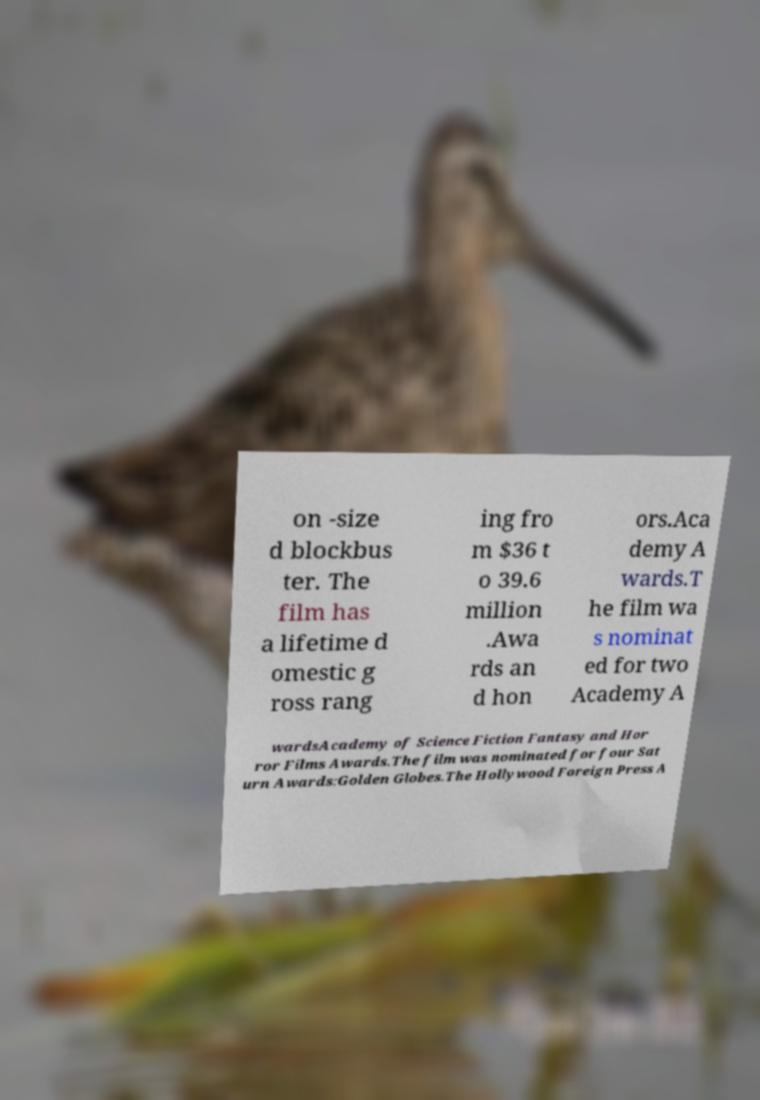Can you accurately transcribe the text from the provided image for me? on -size d blockbus ter. The film has a lifetime d omestic g ross rang ing fro m $36 t o 39.6 million .Awa rds an d hon ors.Aca demy A wards.T he film wa s nominat ed for two Academy A wardsAcademy of Science Fiction Fantasy and Hor ror Films Awards.The film was nominated for four Sat urn Awards:Golden Globes.The Hollywood Foreign Press A 